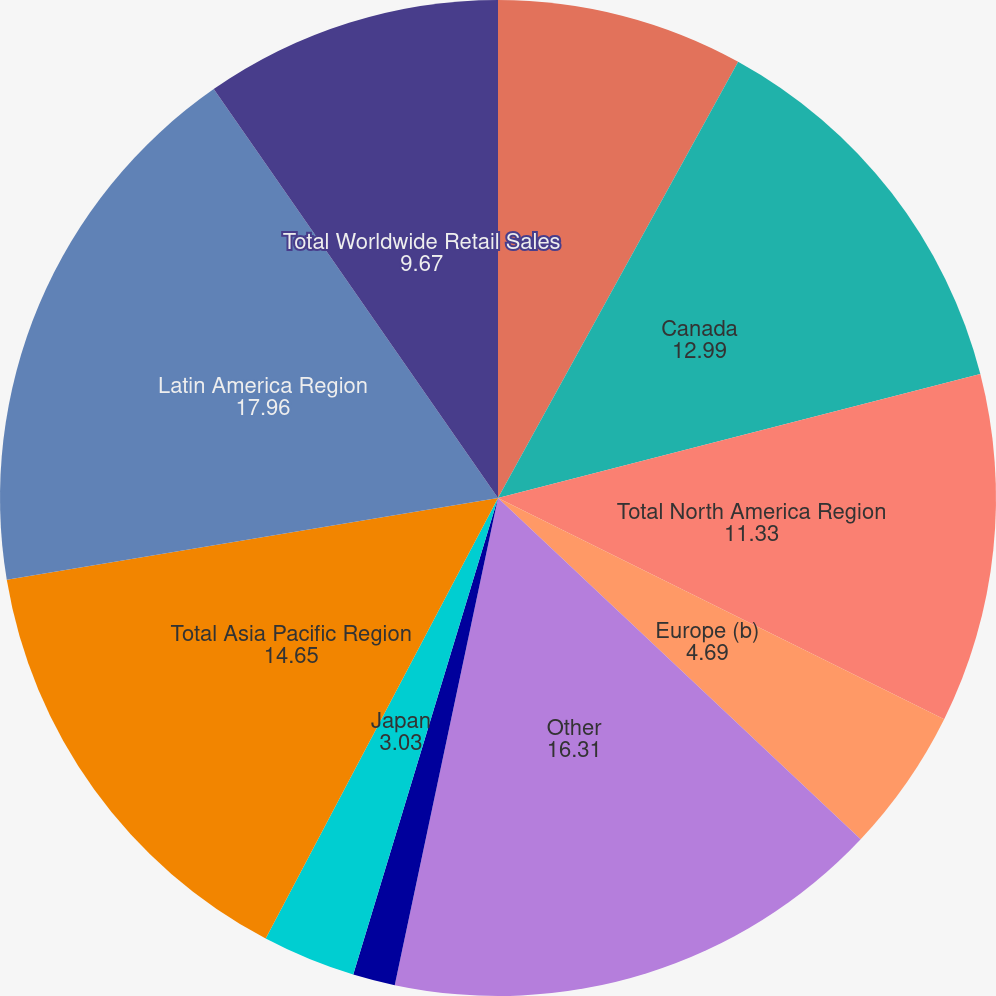<chart> <loc_0><loc_0><loc_500><loc_500><pie_chart><fcel>United States<fcel>Canada<fcel>Total North America Region<fcel>Europe (b)<fcel>Other<fcel>Total EMEA Region<fcel>Japan<fcel>Total Asia Pacific Region<fcel>Latin America Region<fcel>Total Worldwide Retail Sales<nl><fcel>8.01%<fcel>12.99%<fcel>11.33%<fcel>4.69%<fcel>16.31%<fcel>1.37%<fcel>3.03%<fcel>14.65%<fcel>17.96%<fcel>9.67%<nl></chart> 